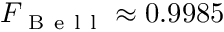<formula> <loc_0><loc_0><loc_500><loc_500>F _ { B e l l } \approx 0 . 9 9 8 5</formula> 